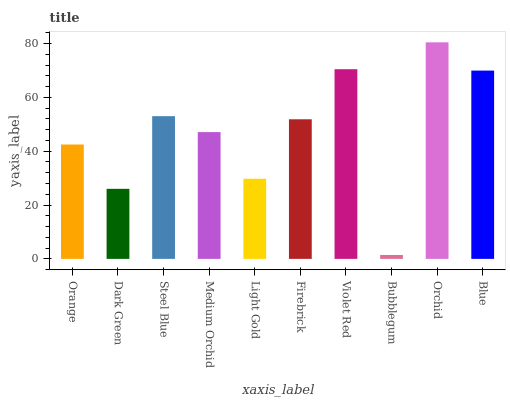Is Bubblegum the minimum?
Answer yes or no. Yes. Is Orchid the maximum?
Answer yes or no. Yes. Is Dark Green the minimum?
Answer yes or no. No. Is Dark Green the maximum?
Answer yes or no. No. Is Orange greater than Dark Green?
Answer yes or no. Yes. Is Dark Green less than Orange?
Answer yes or no. Yes. Is Dark Green greater than Orange?
Answer yes or no. No. Is Orange less than Dark Green?
Answer yes or no. No. Is Firebrick the high median?
Answer yes or no. Yes. Is Medium Orchid the low median?
Answer yes or no. Yes. Is Light Gold the high median?
Answer yes or no. No. Is Blue the low median?
Answer yes or no. No. 